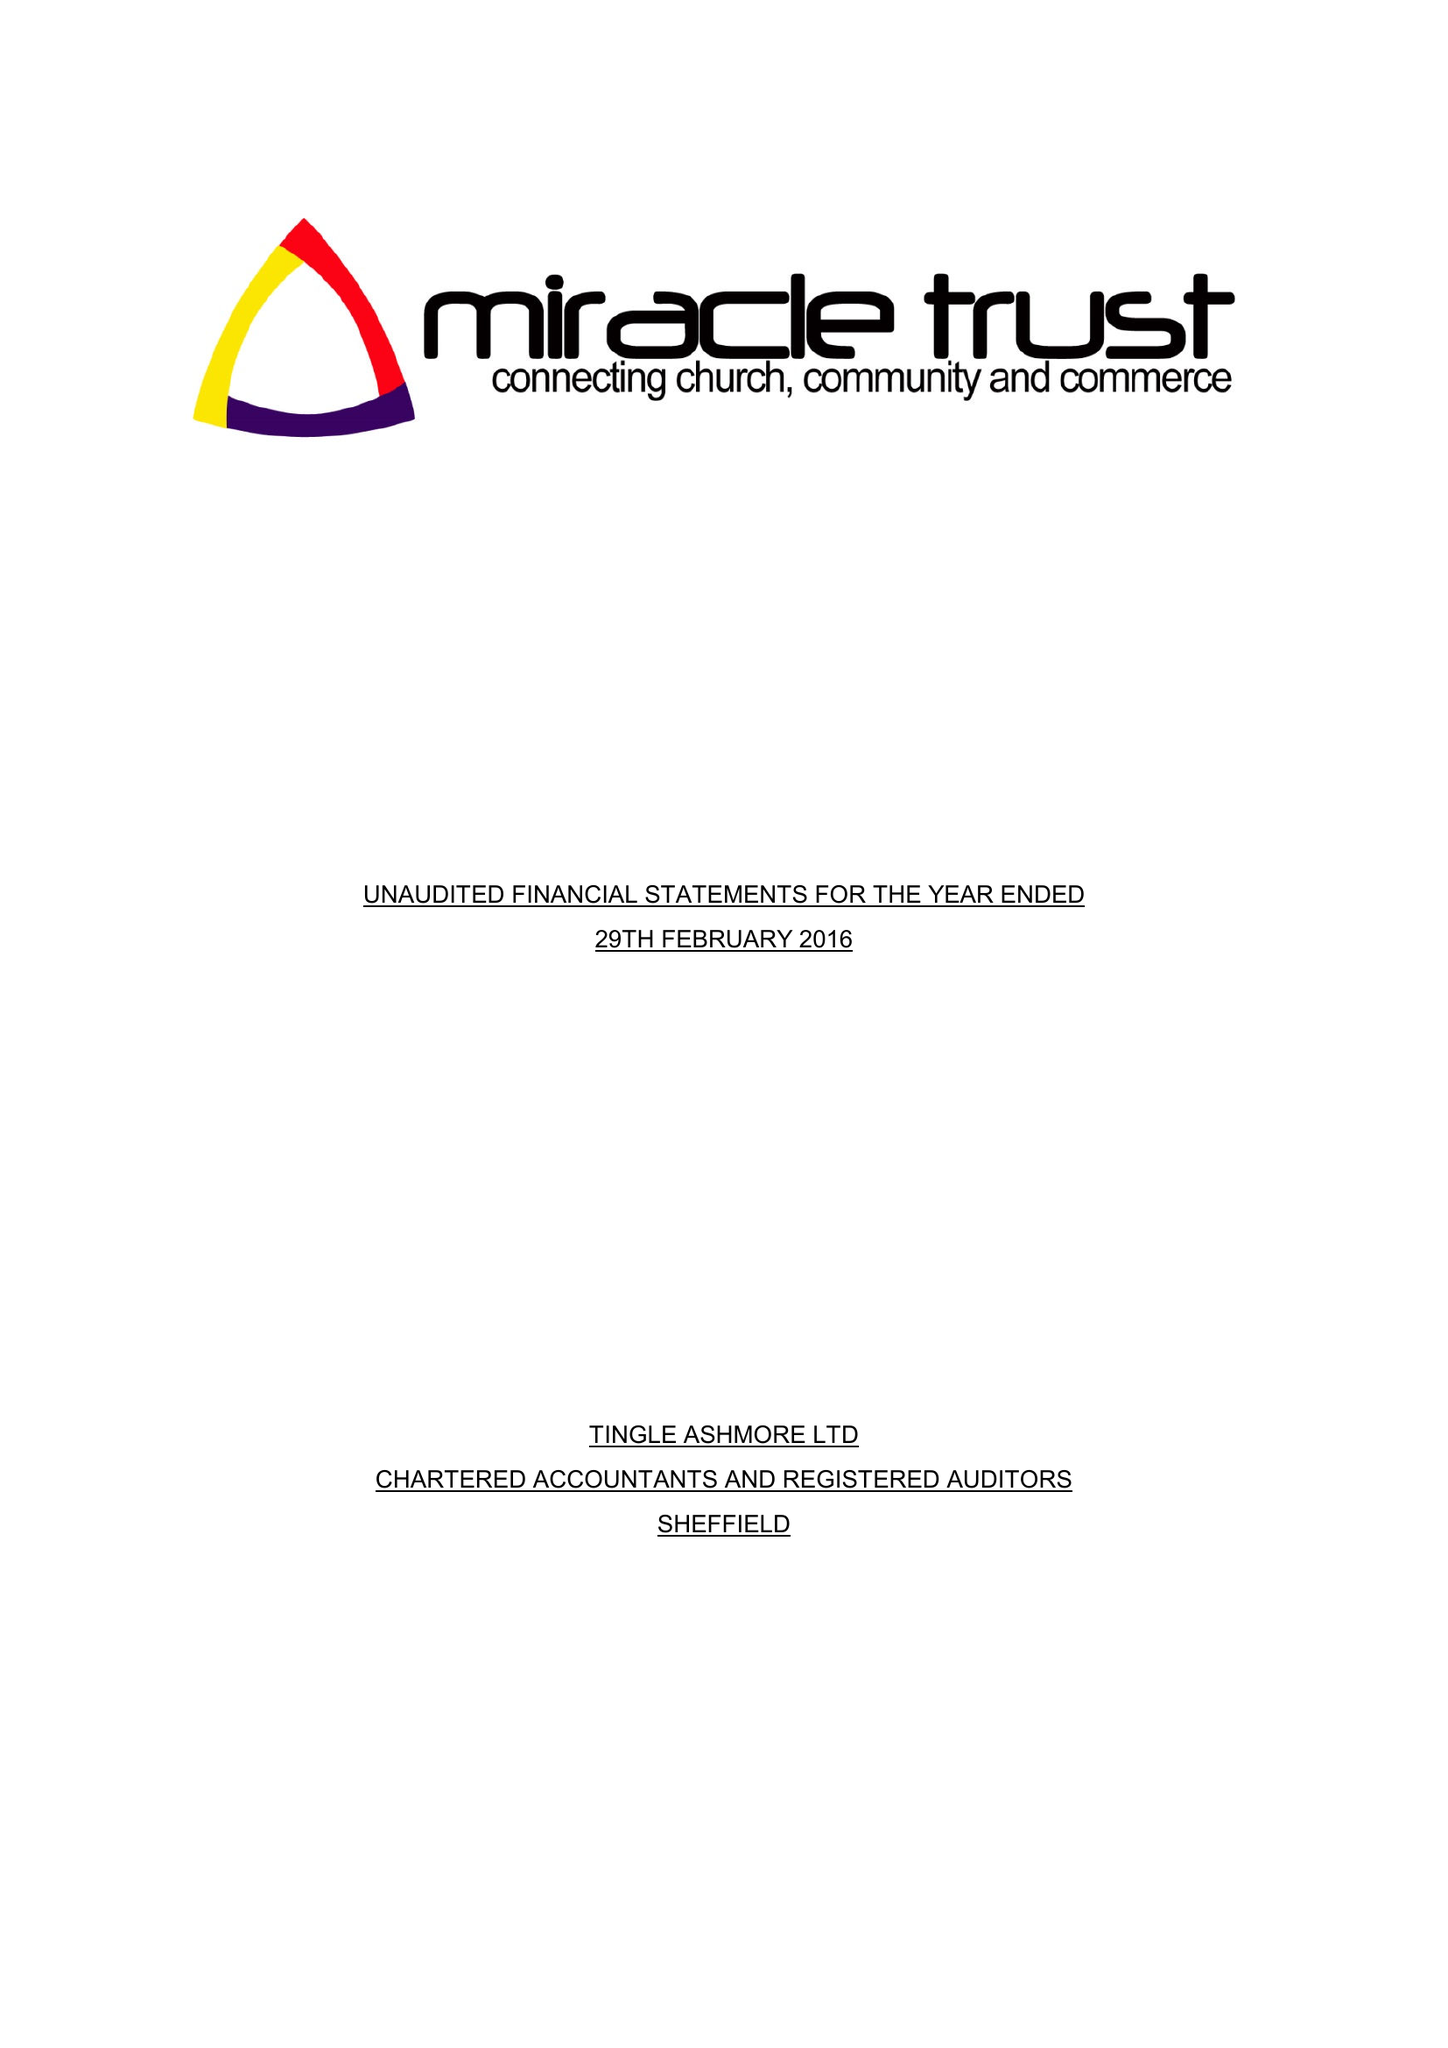What is the value for the charity_number?
Answer the question using a single word or phrase. 1103257 